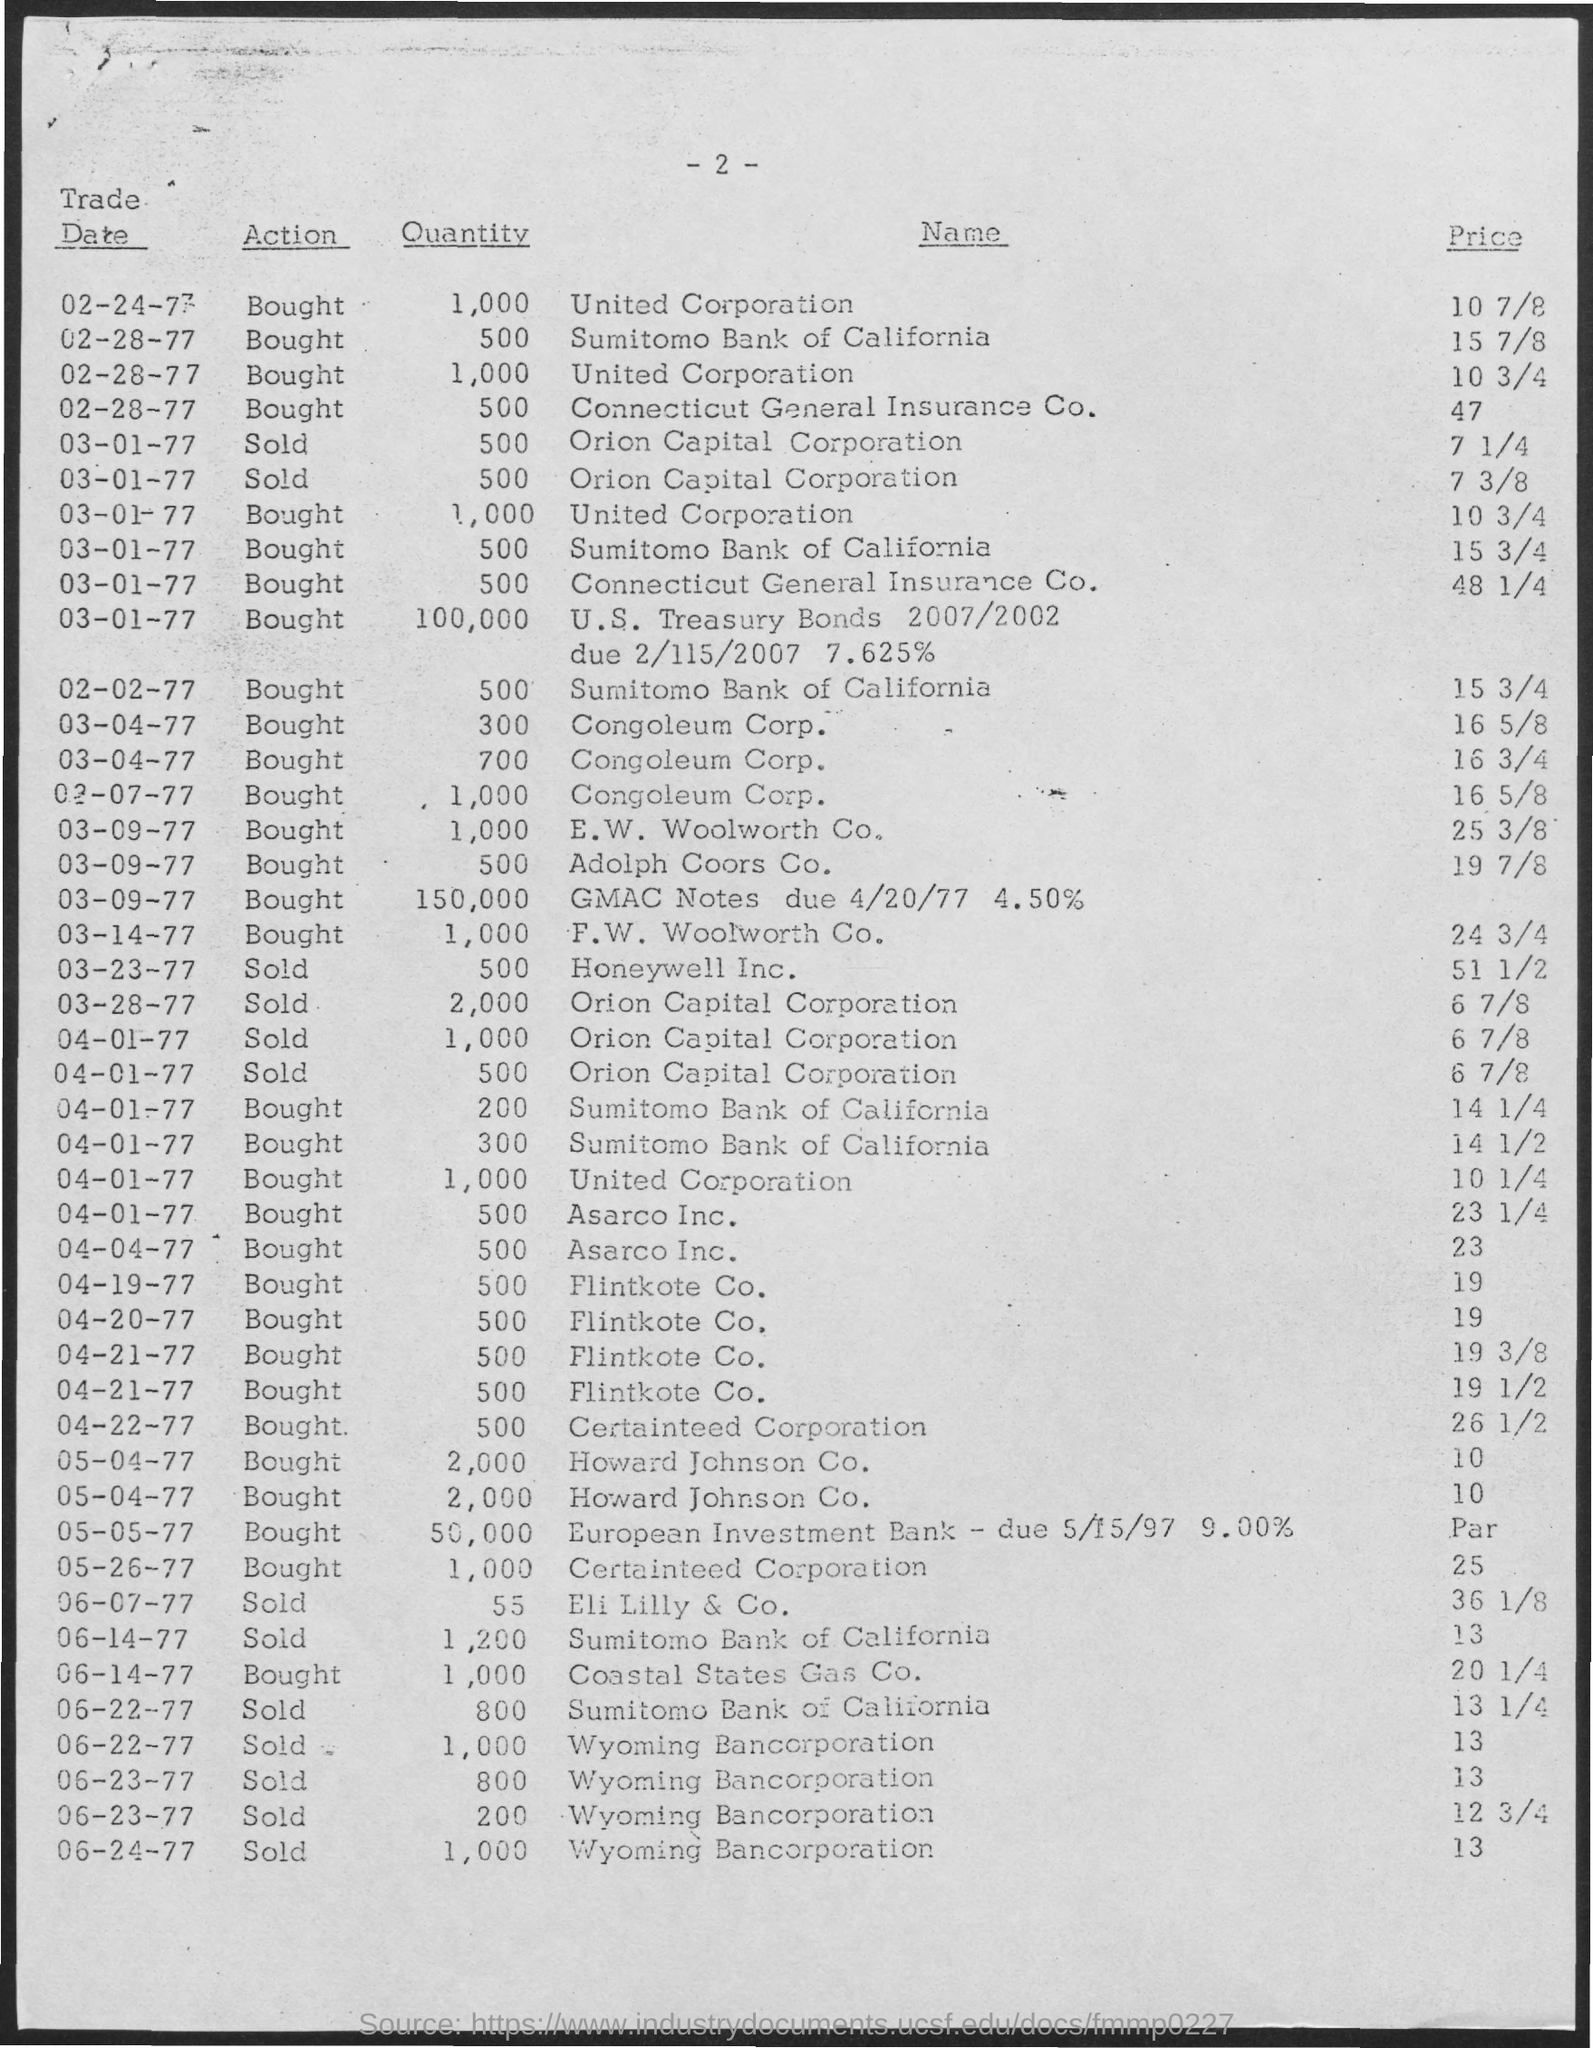What is the Quantity for Trade Date 02-24-77?
Offer a terse response. 1,000. What is the Quantity for Trade Date 02-02-77?
Offer a terse response. 500. What is the Quantity for Trade Date 03-07-77
Make the answer very short. 1,000. What is the Quantity for Trade Date 03-14-77?
Ensure brevity in your answer.  1,000. What is the Quantity for Trade Date 03-23-77?
Provide a succinct answer. 500. What is the Quantity for Trade Date 03-28-77?
Make the answer very short. 2,000. What is the Quantity for Trade Date 04-04-77?
Ensure brevity in your answer.  500. What is the Quantity for Trade Date 04-19-77?
Your answer should be compact. 500. What is the Quantity for Trade Date 04-20-77?
Your answer should be compact. 500. What is the Quantity for Trade Date 04-22-77?
Offer a terse response. 500. 